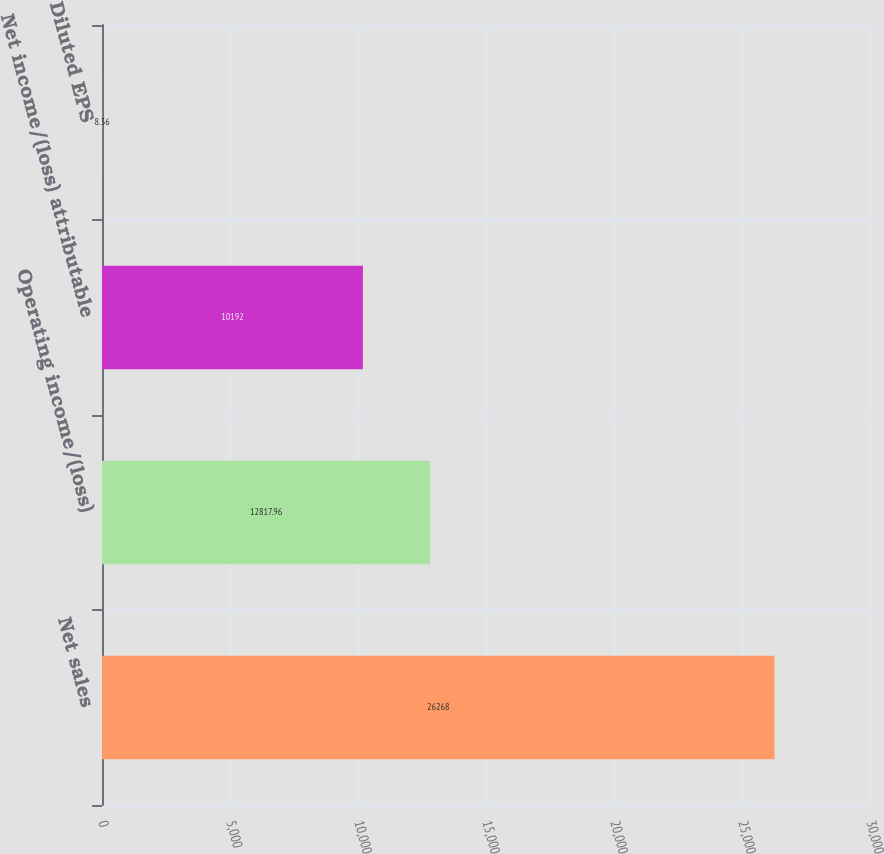<chart> <loc_0><loc_0><loc_500><loc_500><bar_chart><fcel>Net sales<fcel>Operating income/(loss)<fcel>Net income/(loss) attributable<fcel>Diluted EPS<nl><fcel>26268<fcel>12818<fcel>10192<fcel>8.36<nl></chart> 